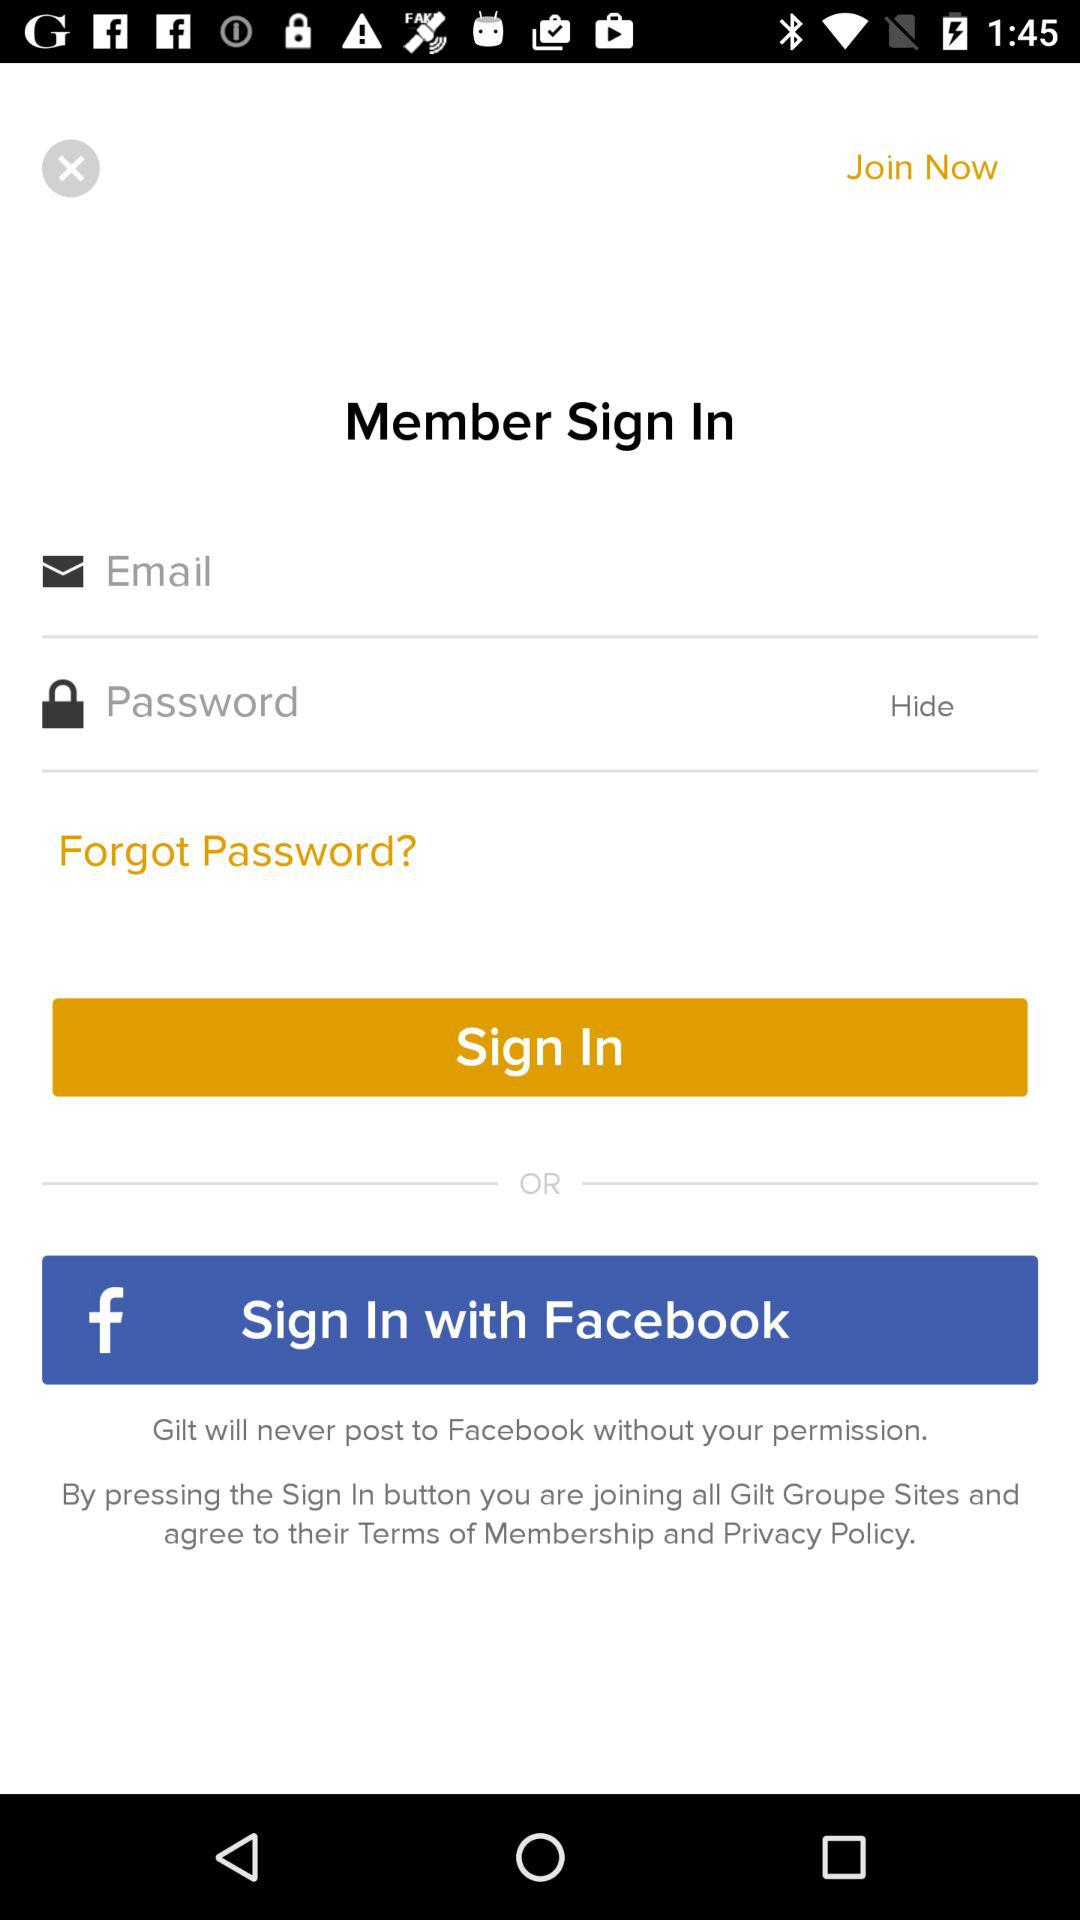What are the different options through which we can sign in? The different options through which you can sign in are "Email" and "Facebook". 